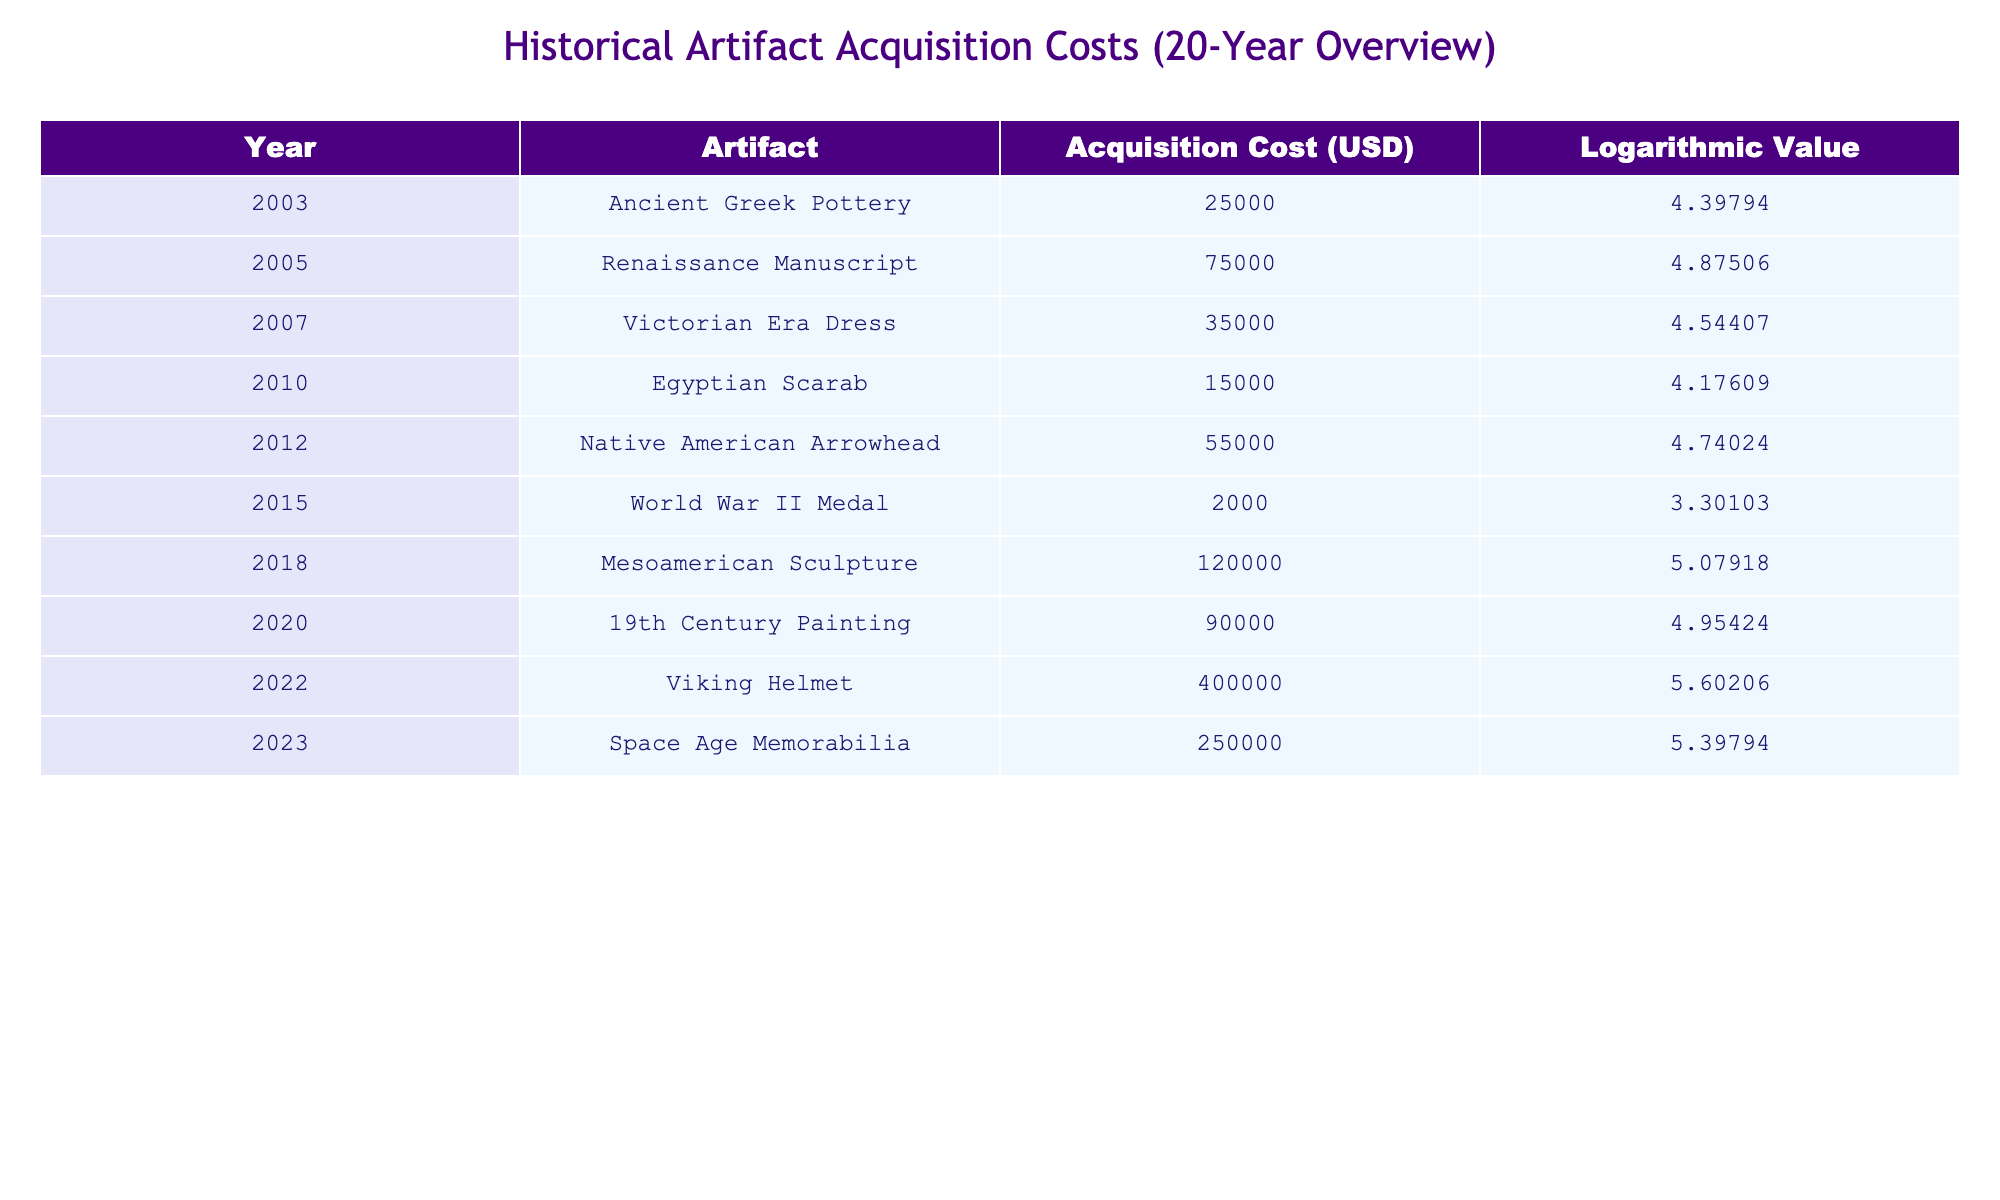What was the acquisition cost of the Renaissance Manuscript? The table lists the acquisition cost for each artifact, and the Renaissance Manuscript is recorded with a cost of 75000 USD in the year 2005.
Answer: 75000 USD Which artifact had the lowest acquisition cost? By inspecting the acquisition costs in the table, the World War II Medal stands out as it has the lowest cost of 2000 USD in the year 2015.
Answer: World War II Medal What is the total acquisition cost of all artifacts acquired between 2003 and 2012? To find this, we will sum the acquisition costs from the years in question: 25000 (2003) + 75000 (2005) + 35000 (2007) + 15000 (2010) + 55000 (2012), which equals 25000 + 75000 + 35000 + 15000 + 55000 = 205000 USD.
Answer: 205000 USD Did the acquisition cost of artifacts generally increase or decrease over the last 20 years? Looking at the acquisition costs over the years, we can see that they experienced fluctuations but ultimately rose, particularly with the Viking Helmet at 400000 USD in 2022 compared to earlier.
Answer: Yes, generally increased What was the average acquisition cost of artifacts from 2010 to 2023? The acquisition costs from 2010 to 2023 are: 15000 (2010) + 55000 (2012) + 2000 (2015) + 120000 (2018) + 90000 (2020) + 400000 (2022) + 250000 (2023). Summing these gives 15000 + 55000 + 2000 + 120000 + 90000 + 400000 + 250000 =  330000 USD. There are 7 data points, so we calculate the average as 330000/7, which results in approximately 47142.86 USD.
Answer: Approximately 47142.86 USD Which two artifacts had acquisition costs that exceeded 100000 USD? By reviewing the table, we can identify the Mesoamerican Sculpture (120000 USD in 2018) and the Viking Helmet (400000 USD in 2022) as having costs over 100000 USD.
Answer: Mesoamerican Sculpture and Viking Helmet Calculate the difference in acquisition costs between the highest and the lowest artifact cost over the years. The greatest acquisition cost is the Viking Helmet at 400000 USD (2022), and the lowest is the World War II Medal at 2000 USD (2015). Thus, the difference is calculated as 400000 - 2000 = 398000 USD.
Answer: 398000 USD List the artifacts acquired before the year 2010 and state their average acquisition cost. The artifacts acquired before 2010 include Ancient Greek Pottery (25000 USD in 2003), Renaissance Manuscript (75000 USD in 2005), Victorian Era Dress (35000 USD in 2007), and Egyptian Scarab (15000 USD in 2010). Their total cost is 25000 + 75000 + 35000 + 15000 = 100000 USD, and the average is 100000/4, equaling 25000 USD.
Answer: 25000 USD 